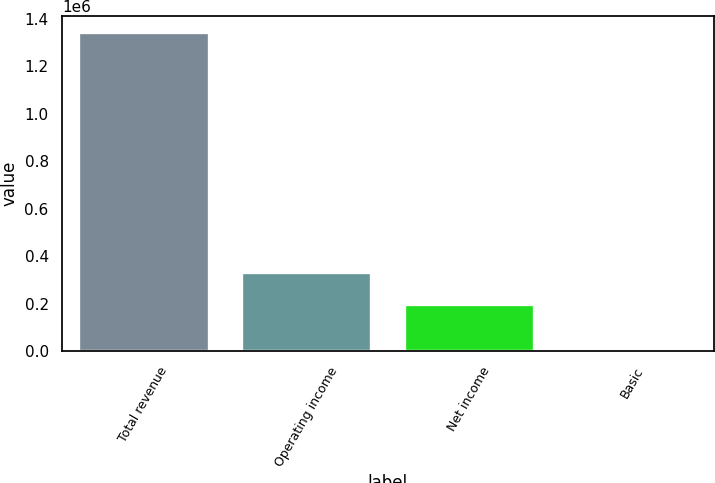Convert chart. <chart><loc_0><loc_0><loc_500><loc_500><bar_chart><fcel>Total revenue<fcel>Operating income<fcel>Net income<fcel>Basic<nl><fcel>1.3441e+06<fcel>332883<fcel>198473<fcel>0.87<nl></chart> 